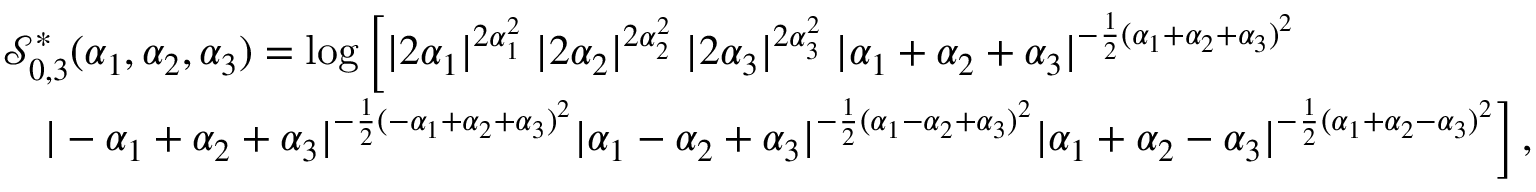Convert formula to latex. <formula><loc_0><loc_0><loc_500><loc_500>\begin{array} { r l } & { \mathcal { S } _ { 0 , 3 } ^ { \ast } ( \alpha _ { 1 } , \alpha _ { 2 } , \alpha _ { 3 } ) = \log \left [ | 2 \alpha _ { 1 } | ^ { 2 \alpha _ { 1 } ^ { 2 } } \, | 2 \alpha _ { 2 } | ^ { 2 \alpha _ { 2 } ^ { 2 } } \, | 2 \alpha _ { 3 } | ^ { 2 \alpha _ { 3 } ^ { 2 } } \, | \alpha _ { 1 } + \alpha _ { 2 } + \alpha _ { 3 } | ^ { - { \frac { 1 } { 2 } } ( \alpha _ { 1 } + \alpha _ { 2 } + \alpha _ { 3 } ) ^ { 2 } } } \\ & { \quad | - \alpha _ { 1 } + \alpha _ { 2 } + \alpha _ { 3 } | ^ { - { \frac { 1 } { 2 } } ( - \alpha _ { 1 } + \alpha _ { 2 } + \alpha _ { 3 } ) ^ { 2 } } | \alpha _ { 1 } - \alpha _ { 2 } + \alpha _ { 3 } | ^ { - { \frac { 1 } { 2 } } ( \alpha _ { 1 } - \alpha _ { 2 } + \alpha _ { 3 } ) ^ { 2 } } | \alpha _ { 1 } + \alpha _ { 2 } - \alpha _ { 3 } | ^ { - { \frac { 1 } { 2 } } ( \alpha _ { 1 } + \alpha _ { 2 } - \alpha _ { 3 } ) ^ { 2 } } \right ] \, , } \end{array}</formula> 